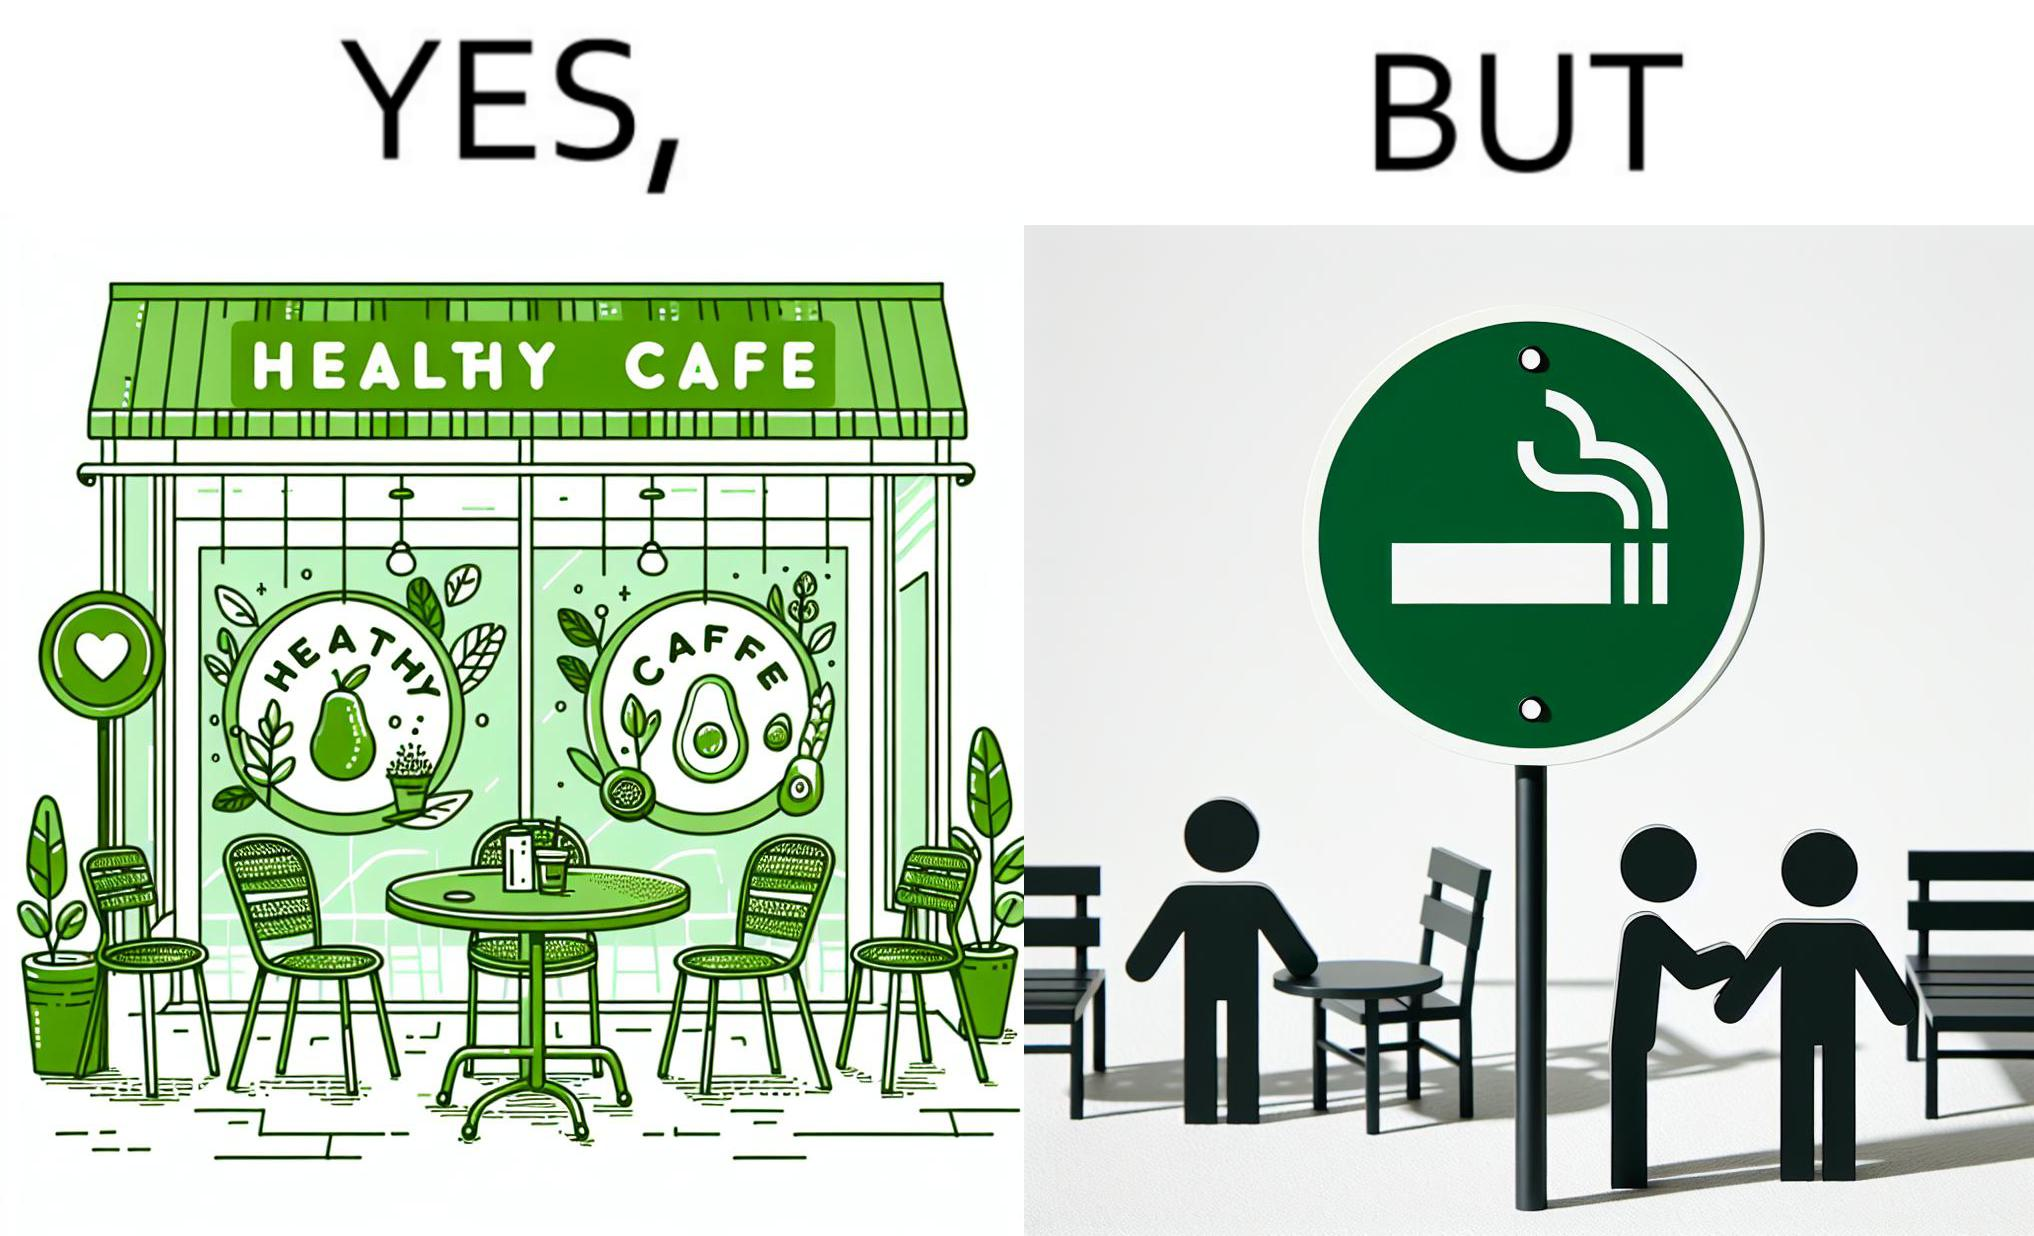What does this image depict? This image is funny because an eatery that calls itself the "healthy" cafe also has a smoking area, which is not very "healthy". If it really was a healthy cafe, it would not have a smoking area as smoking is injurious to health. Satire on the behavior of humans - both those that operate this cafe who made the decision of allowing smoking and creating a designated smoking area, and those that visit this healthy cafe to become "healthy", but then also indulge in very unhealthy habits simultaneously. 